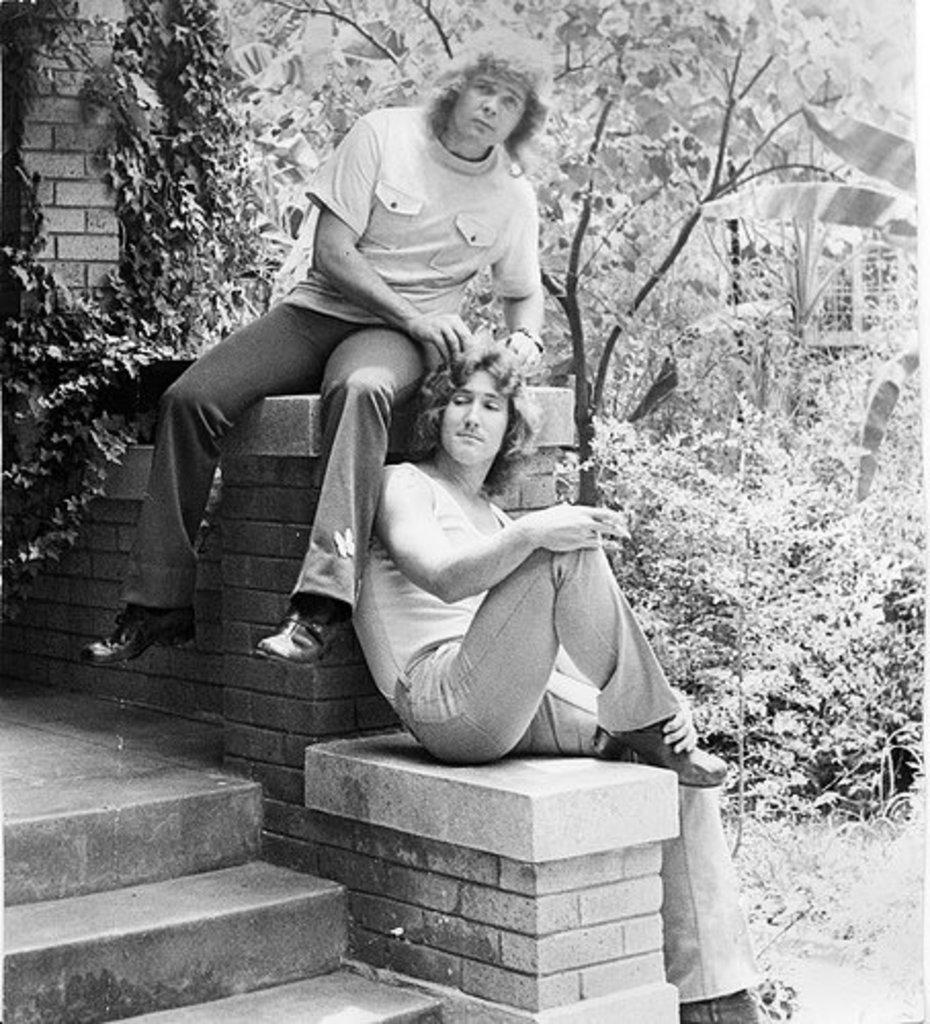How many people are sitting in the image? There are two men sitting in the image. What can be seen on the bottom left side of the image? There is a staircase on the bottom left side of the image. What type of natural scenery is visible in the background of the image? There are trees visible in the background of the image. What color is the brick bear on the north side of the image? There is no brick bear present in the image, and the concept of a "north side" is not applicable to a two-dimensional image. 